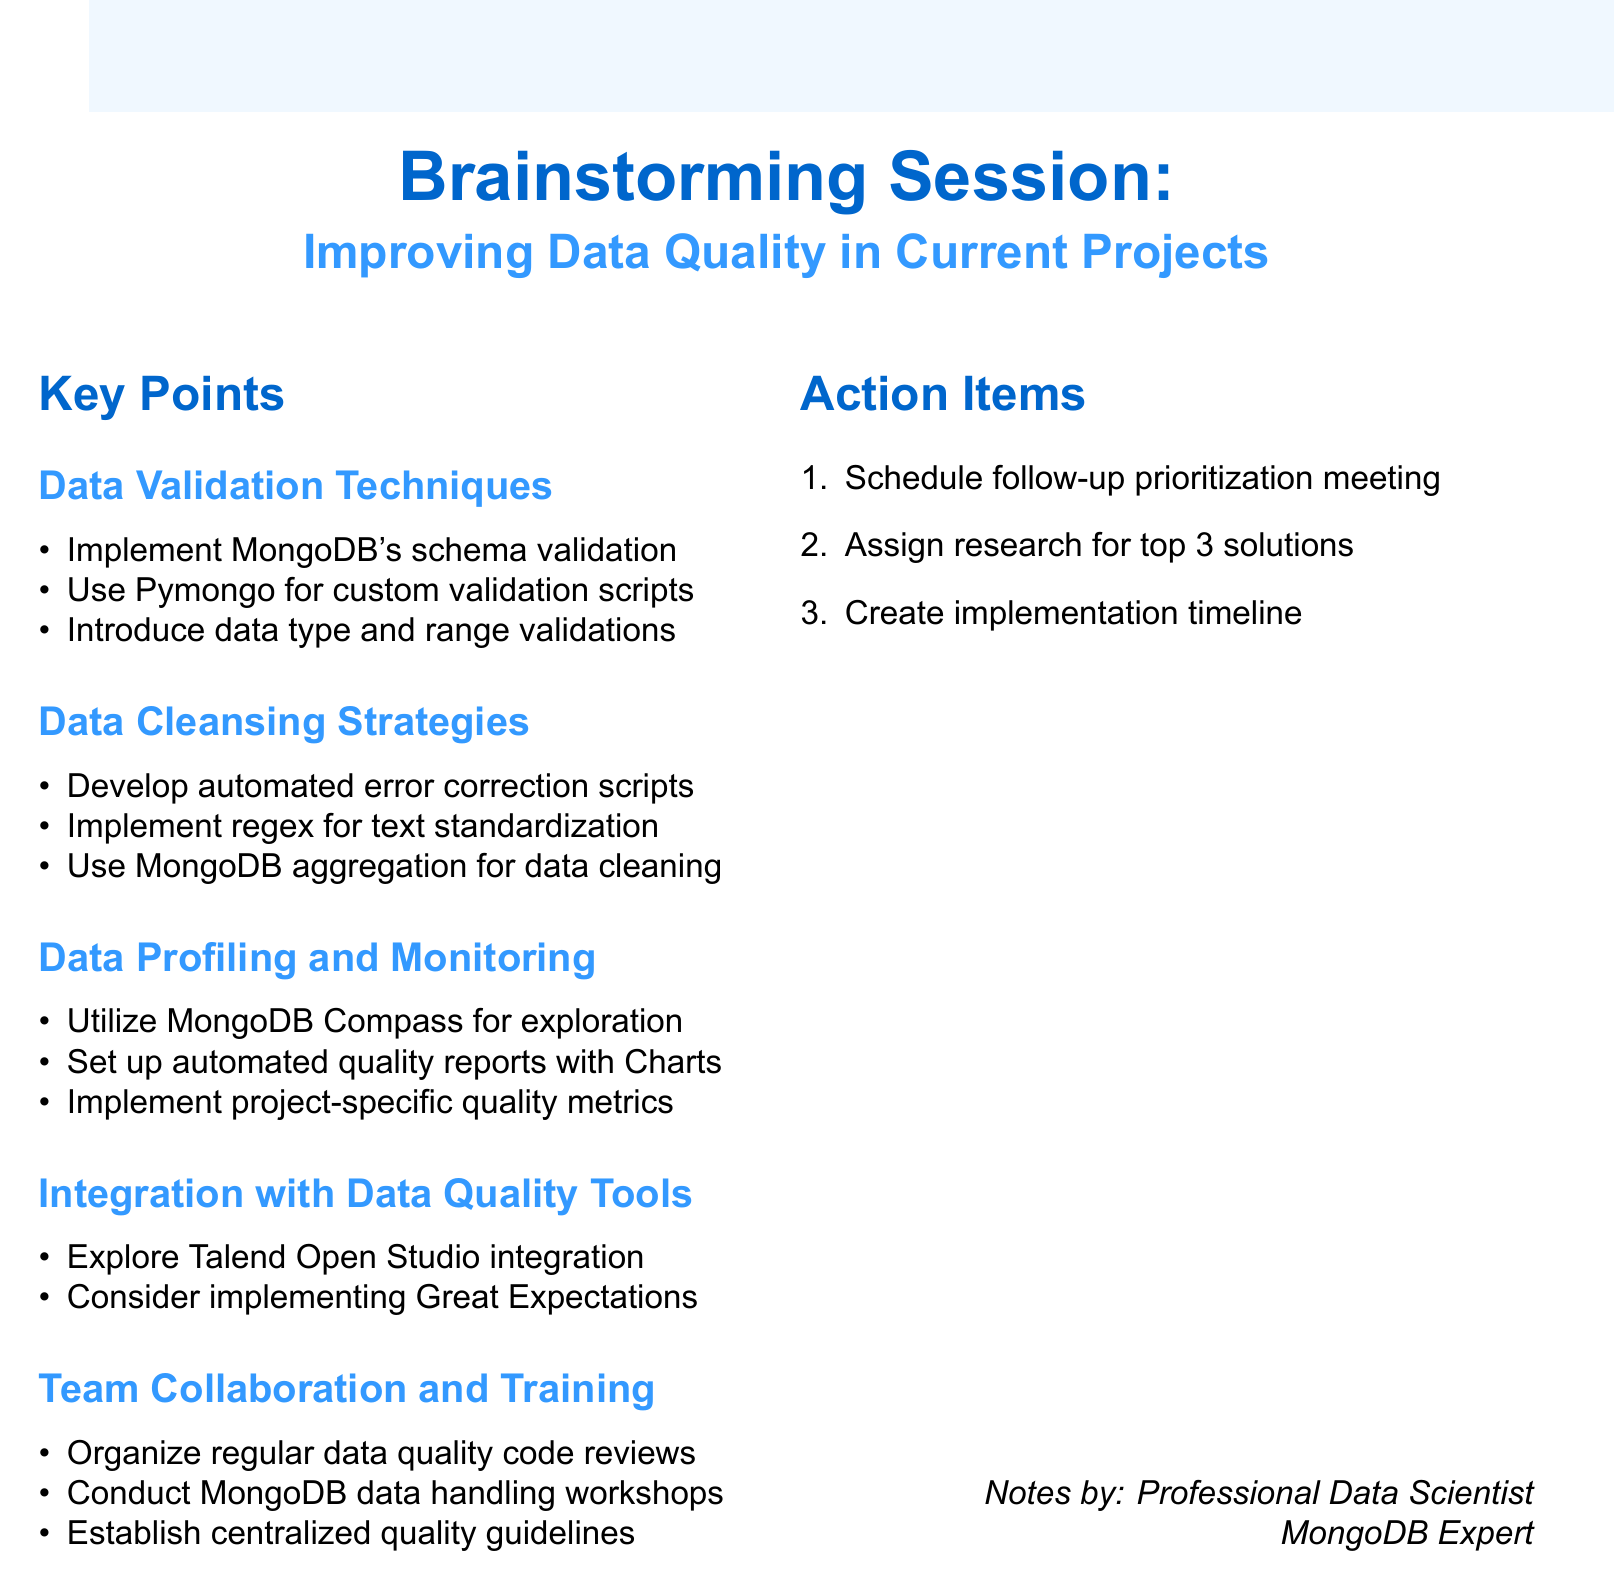What is the title of the session? The title of the session is "Brainstorming Session: Improving Data Quality in Current Projects."
Answer: Brainstorming Session: Improving Data Quality in Current Projects How many key points are there in the document? The document lists five key points under different topics related to data quality.
Answer: Five What is one of the data validation techniques mentioned? The document specifies several techniques, including "Use Pymongo for custom Python-based validation scripts."
Answer: Use Pymongo for custom Python-based validation scripts What tool is suggested for visual data exploration? The document mentions "MongoDB Compass" as a tool for visual data exploration.
Answer: MongoDB Compass What is the first action item listed? The first action item is to "Schedule a follow-up meeting to prioritize identified strategies."
Answer: Schedule a follow-up meeting to prioritize identified strategies Which tool is considered for data testing and documentation integration? The document suggests considering "Great Expectations" for data testing and documentation.
Answer: Great Expectations What is one strategy for team collaboration mentioned? One strategy for collaboration is to "Organize regular code reviews focusing on data quality aspects."
Answer: Organize regular code reviews focusing on data quality aspects Which MongoDB feature is suggested for data transformation and cleaning? The document recommends using "MongoDB's aggregation pipeline for data transformation and cleaning."
Answer: MongoDB's aggregation pipeline for data transformation and cleaning Who is credited with the notes? The notes are credited to a "Professional Data Scientist" and "MongoDB Expert."
Answer: Professional Data Scientist, MongoDB Expert 